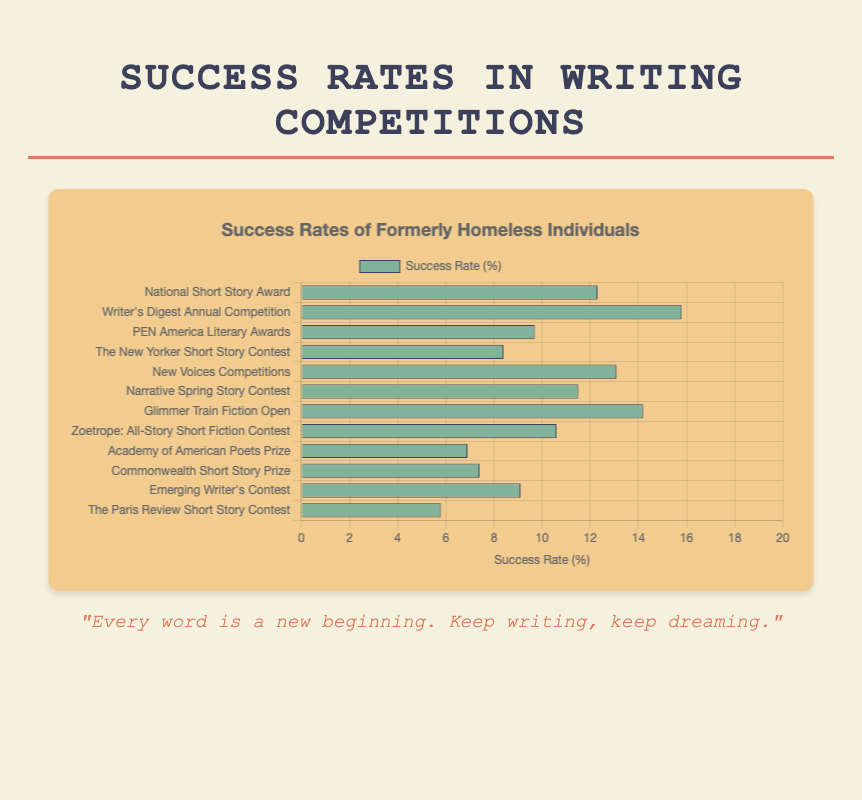Which competition has the highest success rate? The bar representing "Writer's Digest Annual Competition" reaches the farthest to the right, indicating the highest success rate.
Answer: Writer's Digest Annual Competition Which competition has the lowest success rate? The bar representing "The Paris Review Short Story Contest" has the shortest length, indicating the lowest success rate.
Answer: The Paris Review Short Story Contest How much greater is the success rate of the "Writer's Digest Annual Competition" compared to the "PEN America Literary Awards"? "Writer's Digest Annual Competition" has a success rate of 15.8% and "PEN America Literary Awards" has a success rate of 9.7%. The difference is 15.8 - 9.7 = 6.1%.
Answer: 6.1% What is the average success rate of all competitions shown? Add the success rates of all competitions (12.3 + 15.8 + 9.7 + 8.4 + 13.1 + 11.5 + 14.2 + 10.6 + 6.9 + 7.4 + 9.1 + 5.8) to get 125.8. Divide by the number of competitions, which is 12: 125.8 / 12 = 10.48%.
Answer: 10.48% Which competitions have a success rate below 10%? The bars representing "PEN America Literary Awards" (9.7%), "The New Yorker Short Story Contest" (8.4%), "Academy of American Poets Prize" (6.9%), "Commonwealth Short Story Prize" (7.4%), "Emerging Writer's Contest" (9.1%), and "The Paris Review Short Story Contest" (5.8%) do not extend beyond the 10% mark on the chart.
Answer: PEN America Literary Awards, The New Yorker Short Story Contest, Academy of American Poets Prize, Commonwealth Short Story Prize, Emerging Writer's Contest, The Paris Review Short Story Contest What is the difference in success rate between the "New Voices Competitions" and "Narrative Spring Story Contest"? "New Voices Competitions" has a success rate of 13.1% and "Narrative Spring Story Contest" has a success rate of 11.5%. The difference is 13.1 - 11.5 = 1.6%.
Answer: 1.6% Which competition's success rate is closest to the average success rate of 10.48%? Comparing each competition's success rate to 10.48%, "Narrative Spring Story Contest" with a rate of 11.5% is closest to 10.48% (difference of 1.02%).
Answer: Narrative Spring Story Contest What is the total success rate of the competitions with success rates above 12%? The competitions with success rates above 12% are "National Short Story Award" (12.3%), "Writer's Digest Annual Competition" (15.8%), "New Voices Competitions" (13.1%), and "Glimmer Train Fiction Open" (14.2%). Sum these rates: 12.3 + 15.8 + 13.1 + 14.2 = 55.4%.
Answer: 55.4% How much higher is the average success rate compared to the success rate of "The Paris Review Short Story Contest"? Average success rate is 10.48%. The success rate of "The Paris Review Short Story Contest" is 5.8%. The difference is 10.48 - 5.8 = 4.68%.
Answer: 4.68% 